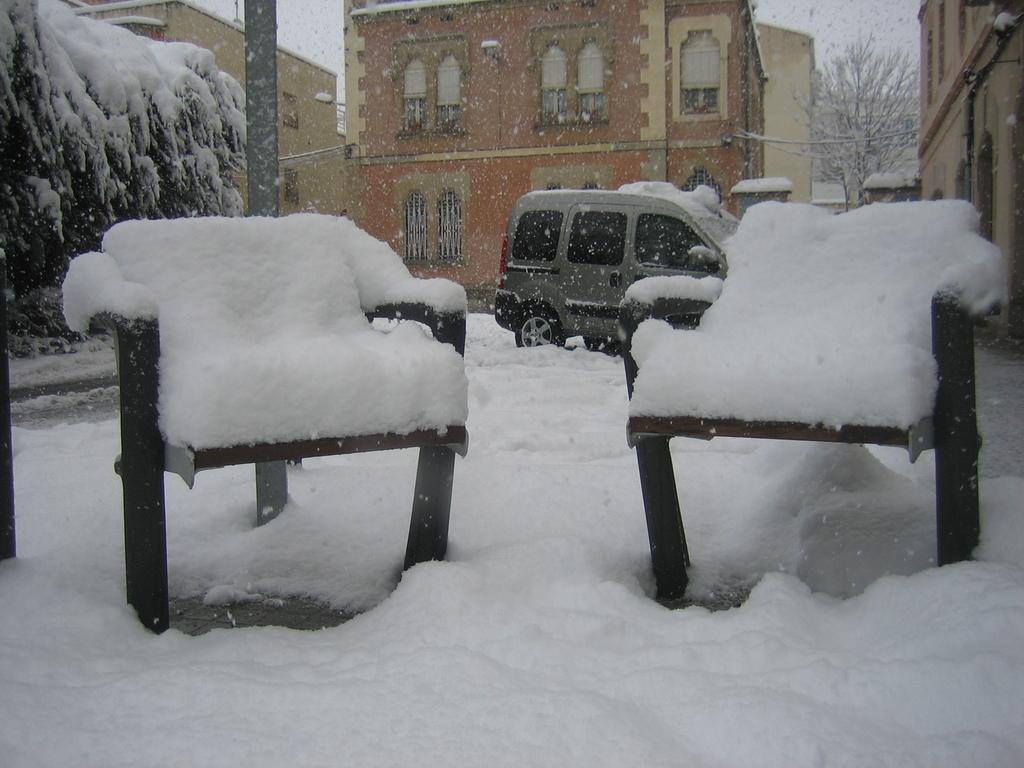Could you give a brief overview of what you see in this image? This image is clicked outside. Everywhere there is snow. There are two chairs in the middle. Back side there is a vehicle. Behind that vehicle there is a building on the top right corner there is a building. There are street lights to that building. There is a tree on the top right corner. There are Windows to that buildings. 